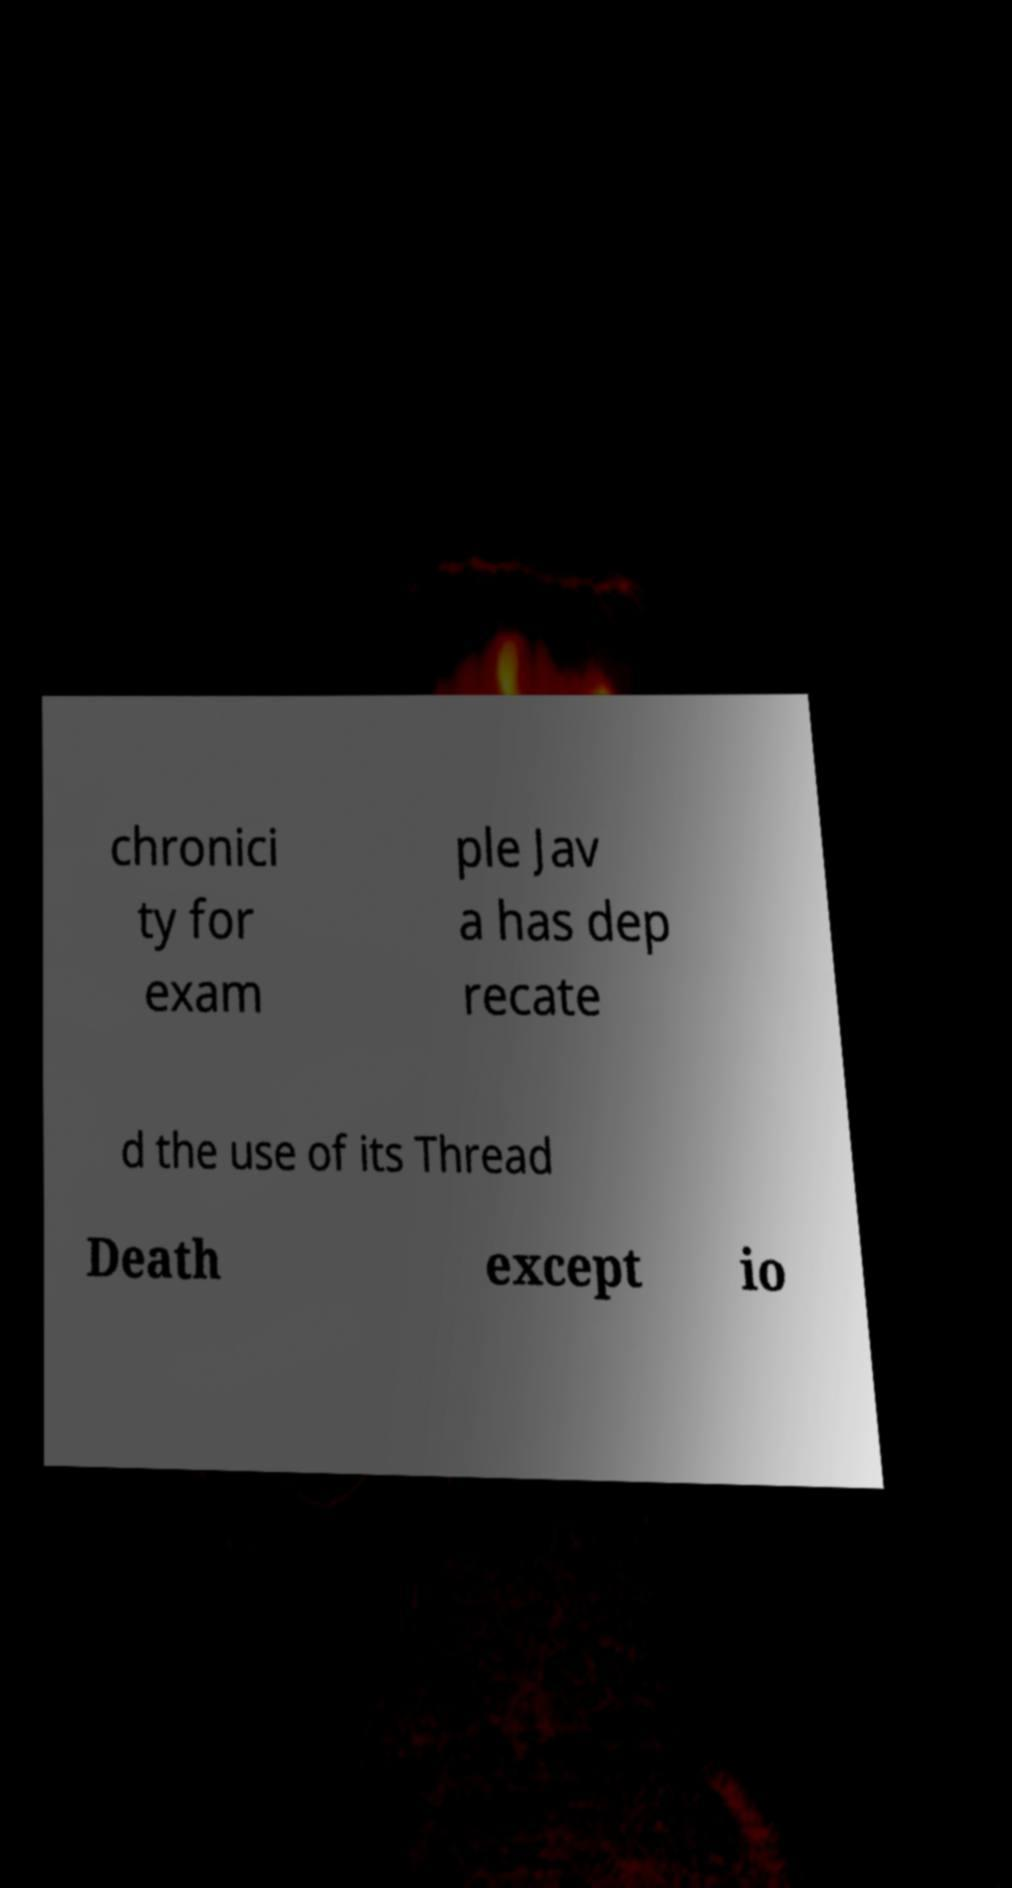There's text embedded in this image that I need extracted. Can you transcribe it verbatim? chronici ty for exam ple Jav a has dep recate d the use of its Thread Death except io 